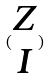Convert formula to latex. <formula><loc_0><loc_0><loc_500><loc_500>( \begin{matrix} Z \\ I \end{matrix} )</formula> 